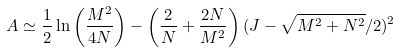<formula> <loc_0><loc_0><loc_500><loc_500>A \simeq \frac { 1 } { 2 } \ln \left ( \frac { M ^ { 2 } } { 4 N } \right ) - \left ( \frac { 2 } { N } + \frac { 2 N } { M ^ { 2 } } \right ) ( J - \sqrt { M ^ { 2 } + N ^ { 2 } } / 2 ) ^ { 2 }</formula> 